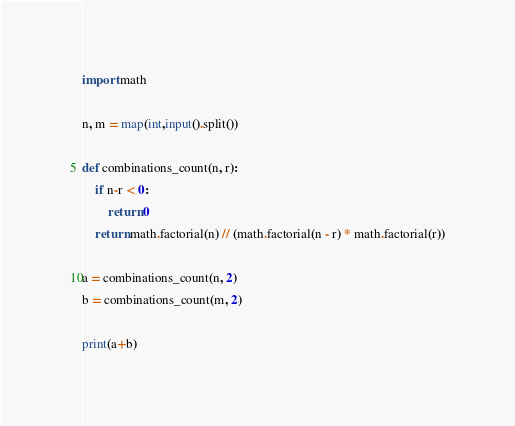Convert code to text. <code><loc_0><loc_0><loc_500><loc_500><_Python_>import math

n, m = map(int,input().split())

def combinations_count(n, r):
    if n-r < 0:
        return 0
    return math.factorial(n) // (math.factorial(n - r) * math.factorial(r))

a = combinations_count(n, 2)
b = combinations_count(m, 2)

print(a+b)</code> 